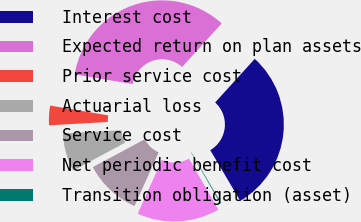Convert chart. <chart><loc_0><loc_0><loc_500><loc_500><pie_chart><fcel>Interest cost<fcel>Expected return on plan assets<fcel>Prior service cost<fcel>Actuarial loss<fcel>Service cost<fcel>Net periodic benefit cost<fcel>Transition obligation (asset)<nl><fcel>29.78%<fcel>34.08%<fcel>3.56%<fcel>6.95%<fcel>10.42%<fcel>15.05%<fcel>0.17%<nl></chart> 